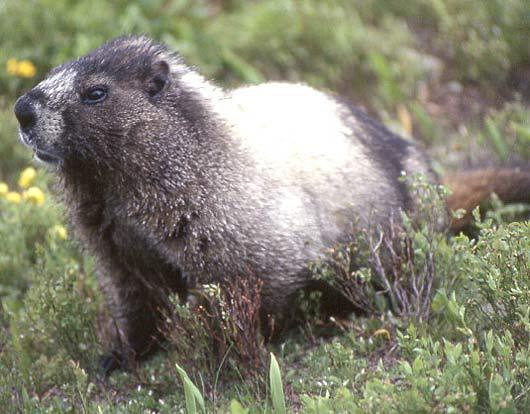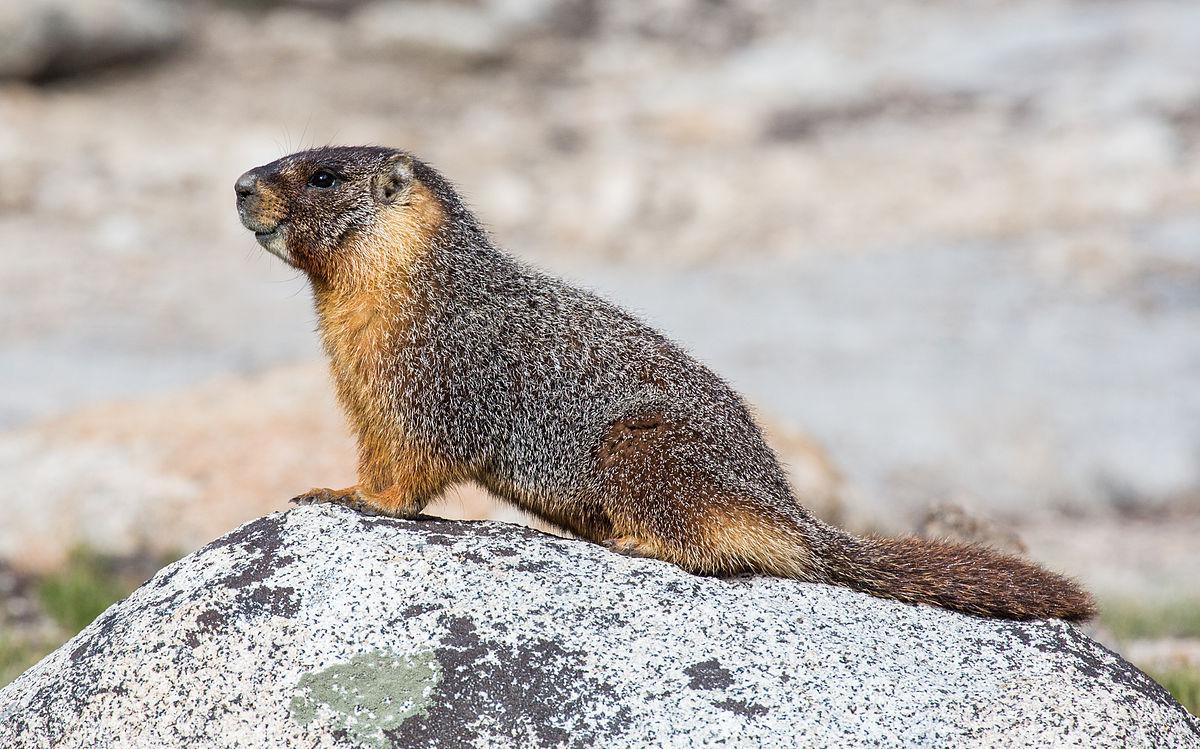The first image is the image on the left, the second image is the image on the right. For the images displayed, is the sentence "There are no more than two rodents." factually correct? Answer yes or no. Yes. The first image is the image on the left, the second image is the image on the right. Given the left and right images, does the statement "The marmots are all a similar color." hold true? Answer yes or no. No. 